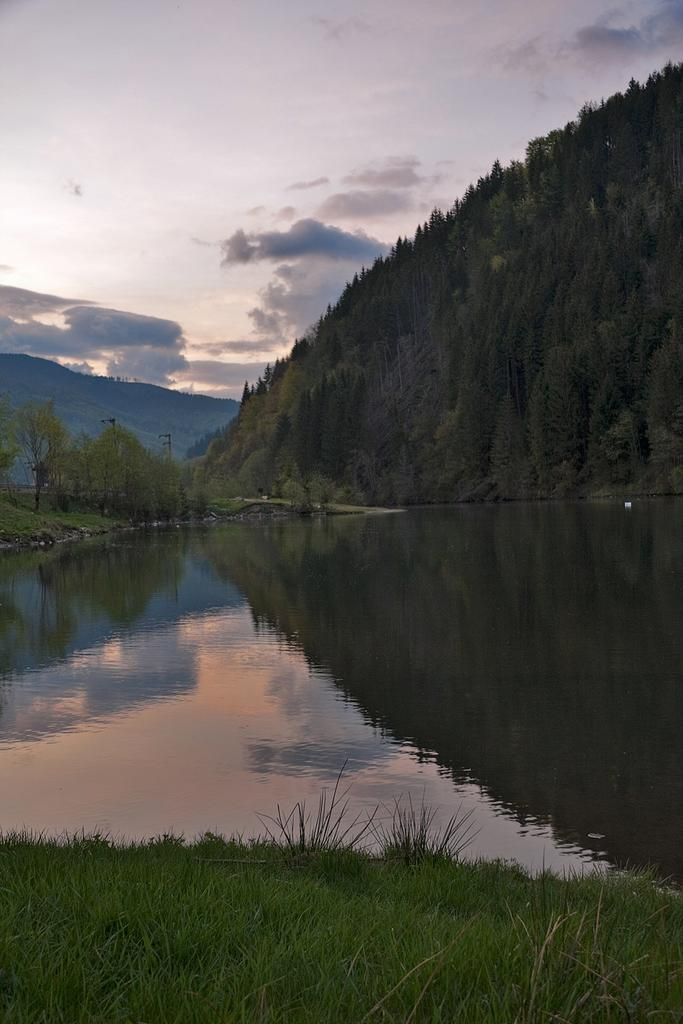What is one of the natural elements present in the image? There is water in the image. What type of vegetation can be seen in the image? There is grass and trees in the image. What geographical feature is visible in the image? There is a mountain in the image. What is visible in the background of the image? The sky is visible in the background of the image. What atmospheric conditions can be observed in the sky? There are clouds in the sky. What type of verse can be heard recited by the cheese in the image? There is no cheese or verse present in the image. How does the mountain pull the clouds closer in the image? The mountain does not pull the clouds closer in the image; the clouds are simply visible in the sky. 